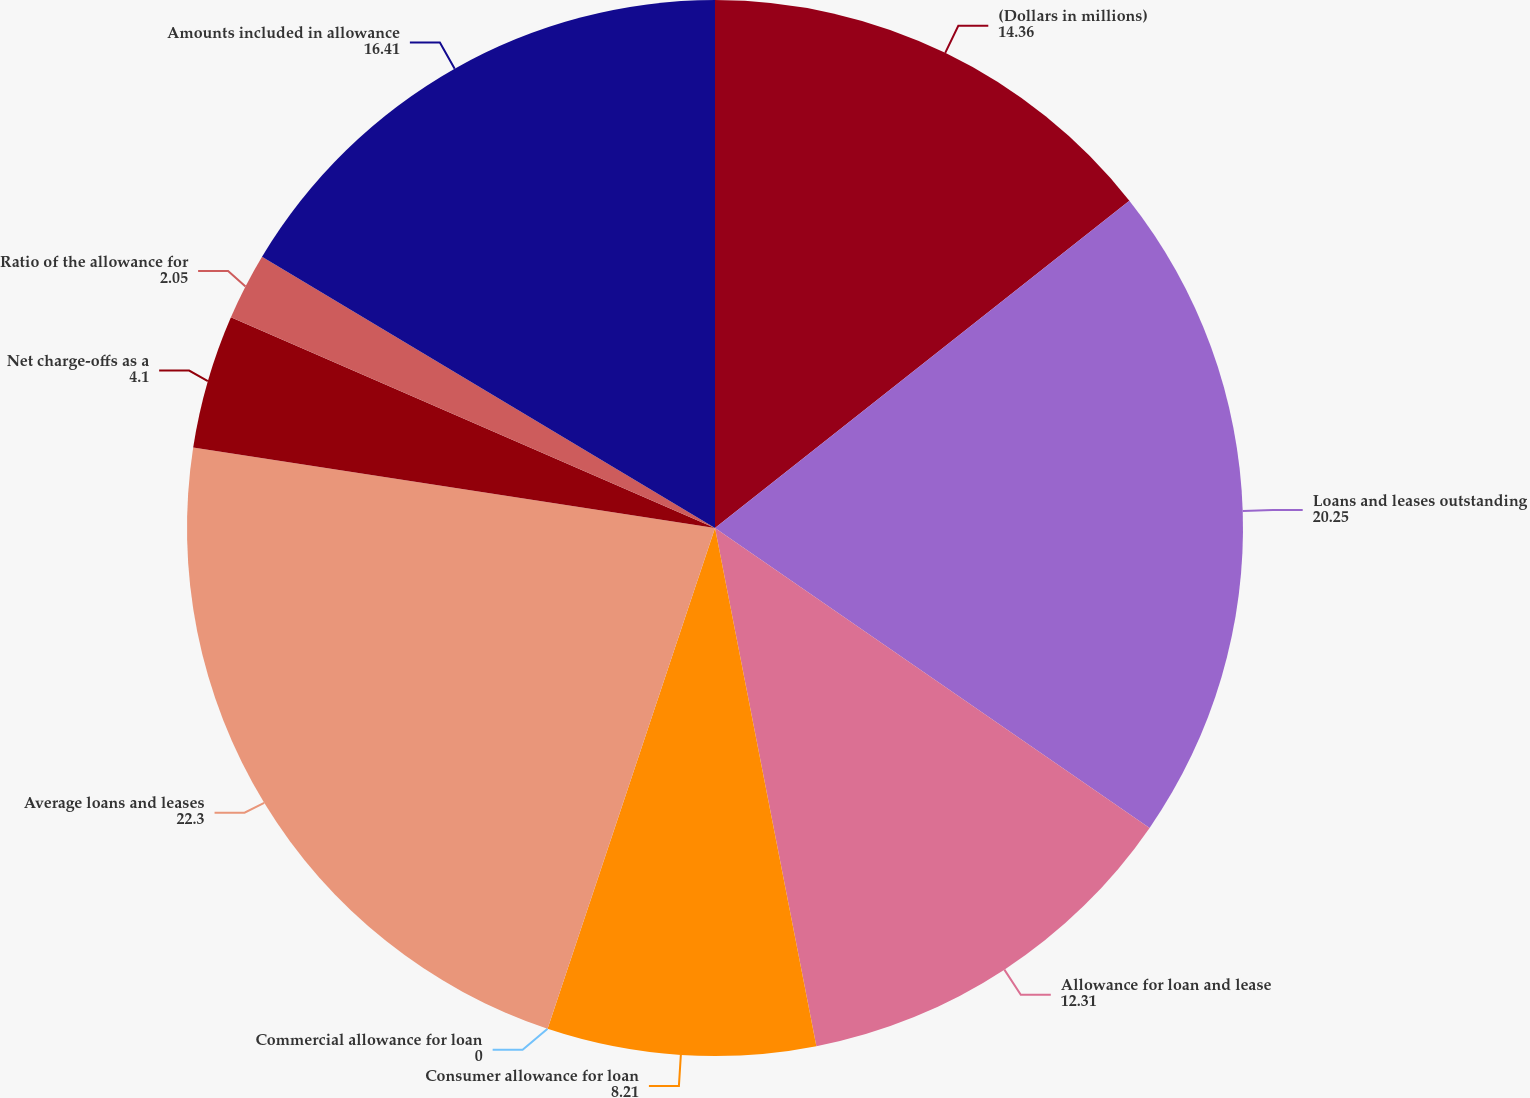<chart> <loc_0><loc_0><loc_500><loc_500><pie_chart><fcel>(Dollars in millions)<fcel>Loans and leases outstanding<fcel>Allowance for loan and lease<fcel>Consumer allowance for loan<fcel>Commercial allowance for loan<fcel>Average loans and leases<fcel>Net charge-offs as a<fcel>Ratio of the allowance for<fcel>Amounts included in allowance<nl><fcel>14.36%<fcel>20.25%<fcel>12.31%<fcel>8.21%<fcel>0.0%<fcel>22.3%<fcel>4.1%<fcel>2.05%<fcel>16.41%<nl></chart> 